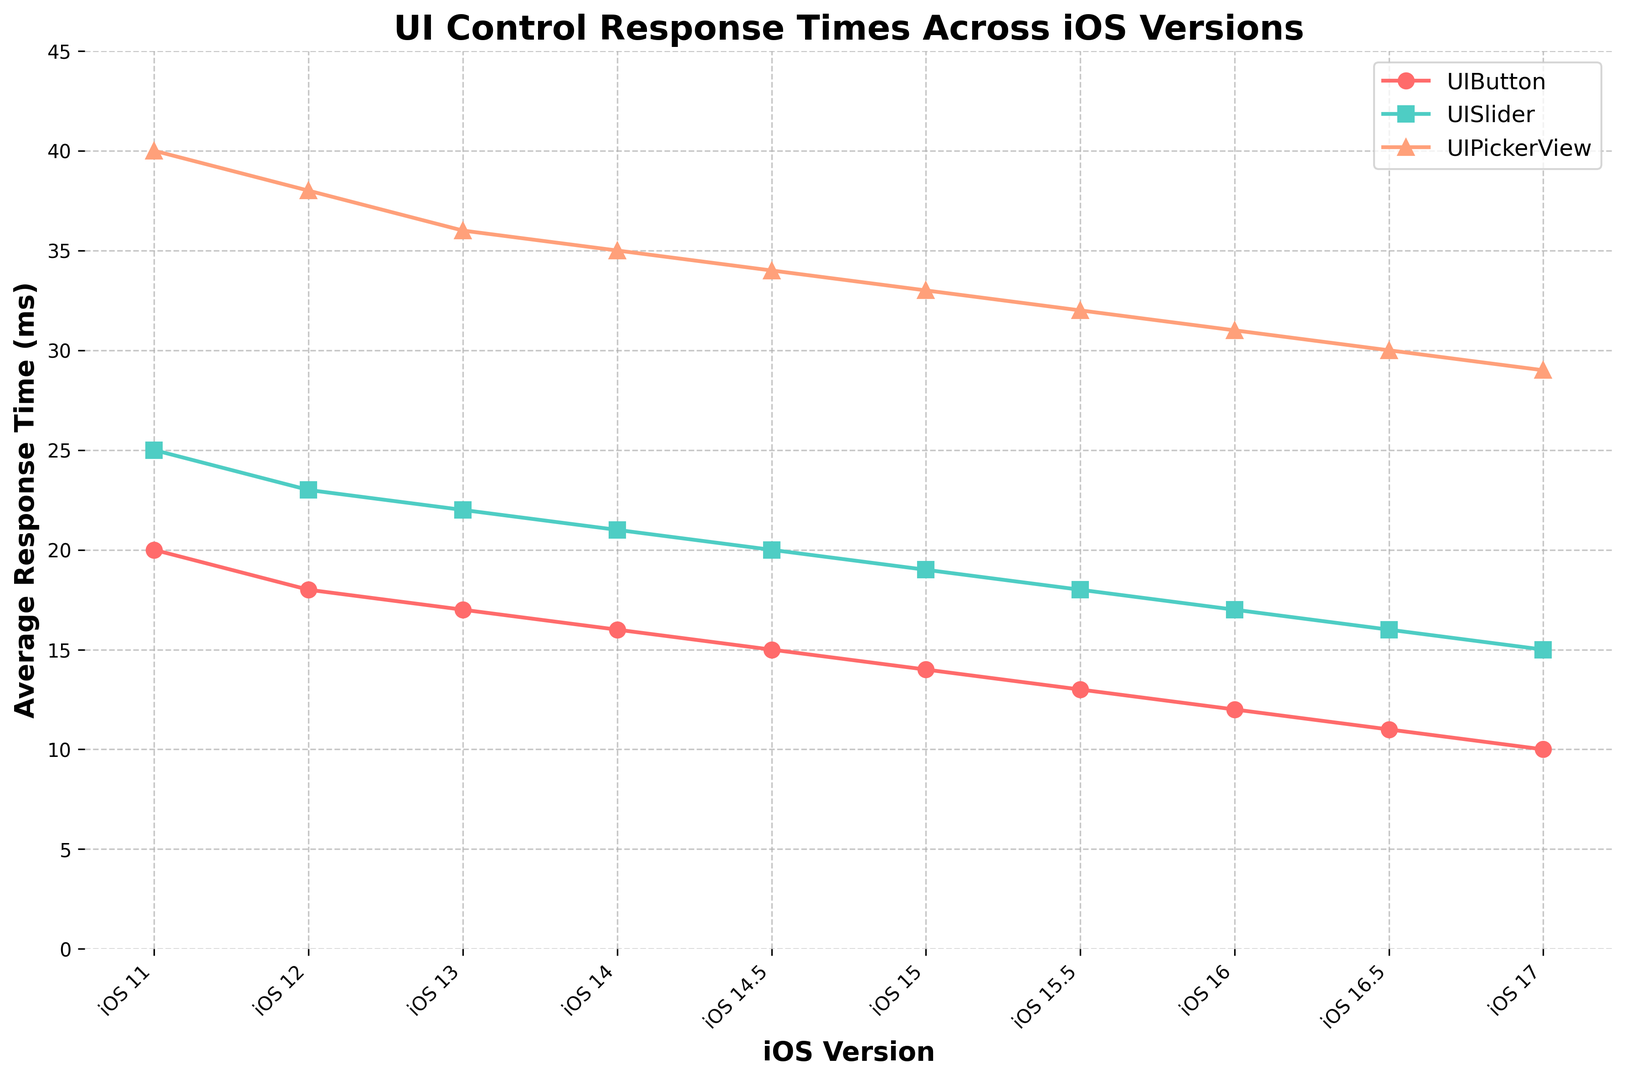What is the average response time for UIButton in iOS 14 and iOS 14.5? First, look at the values for UIButton in iOS 14 and iOS 14.5, which are 16 ms and 15 ms, respectively. Sum these values: 16 ms + 15 ms = 31 ms. Then, divide by 2 to get the average: 31 ms / 2 = 15.5 ms.
Answer: 15.5 ms Which UI control has the highest response time in iOS 11? Observe the response times in iOS 11 for UIButton (20 ms), UISlider (25 ms), and UIPickerView (40 ms). UIPickerView has the highest response time of 40 ms.
Answer: UIPickerView How does the response time of UISlider change from iOS 11 to iOS 17? Look at the response times of UISlider in iOS 11 (25 ms) and iOS 17 (15 ms). Calculate the difference: 25 ms - 15 ms = 10 ms. This shows a decrease of 10 ms.
Answer: Decreases by 10 ms Which iOS version shows the lowest average response time for UI controls? Calculate the average response times for each iOS version and compare them. For instance, the average for iOS 11 is (20+25+40)/3 = 28.33 ms. Do this for all versions. The lowest average is found at iOS 17 with (10+15+29)/3 = 18 ms.
Answer: iOS 17 Which iOS version has the most significant decrease in response time for UIPickerView compared to the previous version? Compare the response times for UIPickerView across sequential iOS versions. The largest decrease is observed between iOS 16.5 (30 ms) and iOS 17 (29 ms), with a difference of 1 ms.
Answer: iOS 17 What is the pattern of UIPickerView's response time from iOS 11 to iOS 17? Examine the trend line of UIPickerView’s response times: 40 ms, 38 ms, 36 ms, 35 ms, 34 ms, 33 ms, 32 ms, 31 ms, 30 ms, 29 ms. It consistently decreases over each iOS version.
Answer: Decreasing How does the response time of UIButton compare to UISlider in iOS 15? Look at the data for iOS 15: UIButton (14 ms) and UISlider (19 ms). UIButton has a faster (lower) response time compared to UISlider.
Answer: UIButton is faster What is the total response time for all UI controls in iOS 12? Sum the response times for UIButton, UISlider, and UIPickerView in iOS 12: 18 ms + 23 ms + 38 ms = 79 ms.
Answer: 79 ms What is the color of the line representing UISlider in the plot? Observe the plot: UISlider is represented by a green-colored line.
Answer: Green By how much does the response time of UIPickerView decrease from iOS 11 to iOS 14.5? Identify the response times for UIPickerView in iOS 11 (40 ms) and iOS 14.5 (34 ms). Calculate the decrease: 40 ms - 34 ms = 6 ms.
Answer: 6 ms 